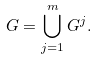<formula> <loc_0><loc_0><loc_500><loc_500>G = \bigcup _ { j = 1 } ^ { m } G ^ { j } .</formula> 